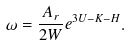Convert formula to latex. <formula><loc_0><loc_0><loc_500><loc_500>\omega = \frac { A _ { r } } { 2 W } e ^ { 3 U - K - H } .</formula> 